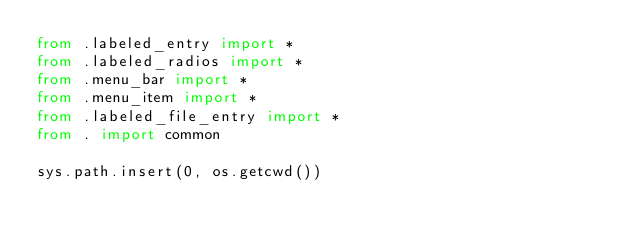<code> <loc_0><loc_0><loc_500><loc_500><_Python_>from .labeled_entry import *
from .labeled_radios import *
from .menu_bar import *
from .menu_item import *
from .labeled_file_entry import *
from . import common

sys.path.insert(0, os.getcwd())
</code> 